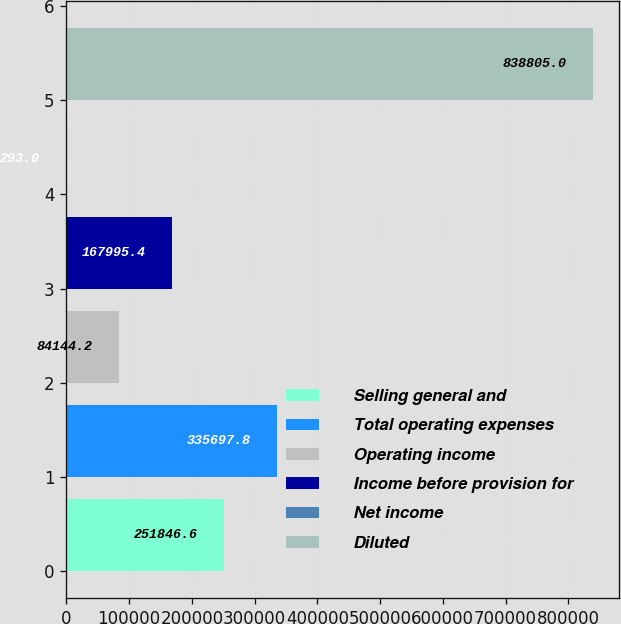Convert chart to OTSL. <chart><loc_0><loc_0><loc_500><loc_500><bar_chart><fcel>Selling general and<fcel>Total operating expenses<fcel>Operating income<fcel>Income before provision for<fcel>Net income<fcel>Diluted<nl><fcel>251847<fcel>335698<fcel>84144.2<fcel>167995<fcel>293<fcel>838805<nl></chart> 